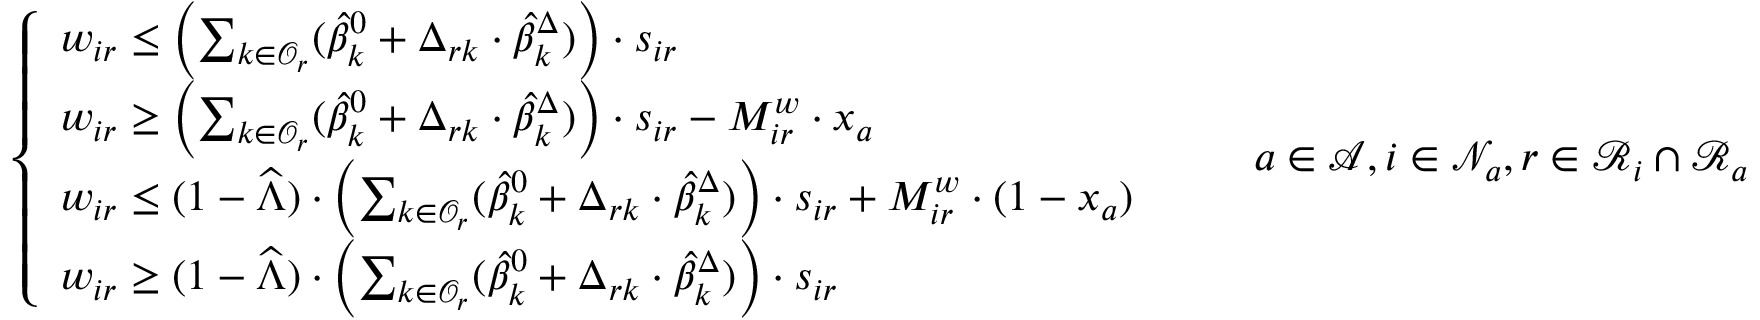<formula> <loc_0><loc_0><loc_500><loc_500>\left \{ \begin{array} { l l } { w _ { i r } \leq \left ( \sum _ { k \in \mathcal { O } _ { r } } ( \widehat { \beta } _ { k } ^ { 0 } + \Delta _ { r k } \cdot \widehat { \beta } _ { k } ^ { \Delta } ) \right ) \cdot s _ { i r } } \\ { w _ { i r } \geq \left ( \sum _ { k \in \mathcal { O } _ { r } } ( \widehat { \beta } _ { k } ^ { 0 } + \Delta _ { r k } \cdot \widehat { \beta } _ { k } ^ { \Delta } ) \right ) \cdot s _ { i r } - M _ { i r } ^ { w } \cdot x _ { a } } \\ { w _ { i r } \leq ( 1 - \widehat { \Lambda } ) \cdot \left ( \sum _ { k \in \mathcal { O } _ { r } } ( \widehat { \beta } _ { k } ^ { 0 } + \Delta _ { r k } \cdot \widehat { \beta } _ { k } ^ { \Delta } ) \right ) \cdot s _ { i r } + M _ { i r } ^ { w } \cdot ( 1 - x _ { a } ) } \\ { w _ { i r } \geq ( 1 - \widehat { \Lambda } ) \cdot \left ( \sum _ { k \in \mathcal { O } _ { r } } ( \widehat { \beta } _ { k } ^ { 0 } + \Delta _ { r k } \cdot \widehat { \beta } _ { k } ^ { \Delta } ) \right ) \cdot s _ { i r } } \end{array} \quad a \in \mathcal { A } , i \in \mathcal { N } _ { a } , r \in \mathcal { R } _ { i } \cap \mathcal { R } _ { a }</formula> 